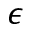Convert formula to latex. <formula><loc_0><loc_0><loc_500><loc_500>\epsilon</formula> 